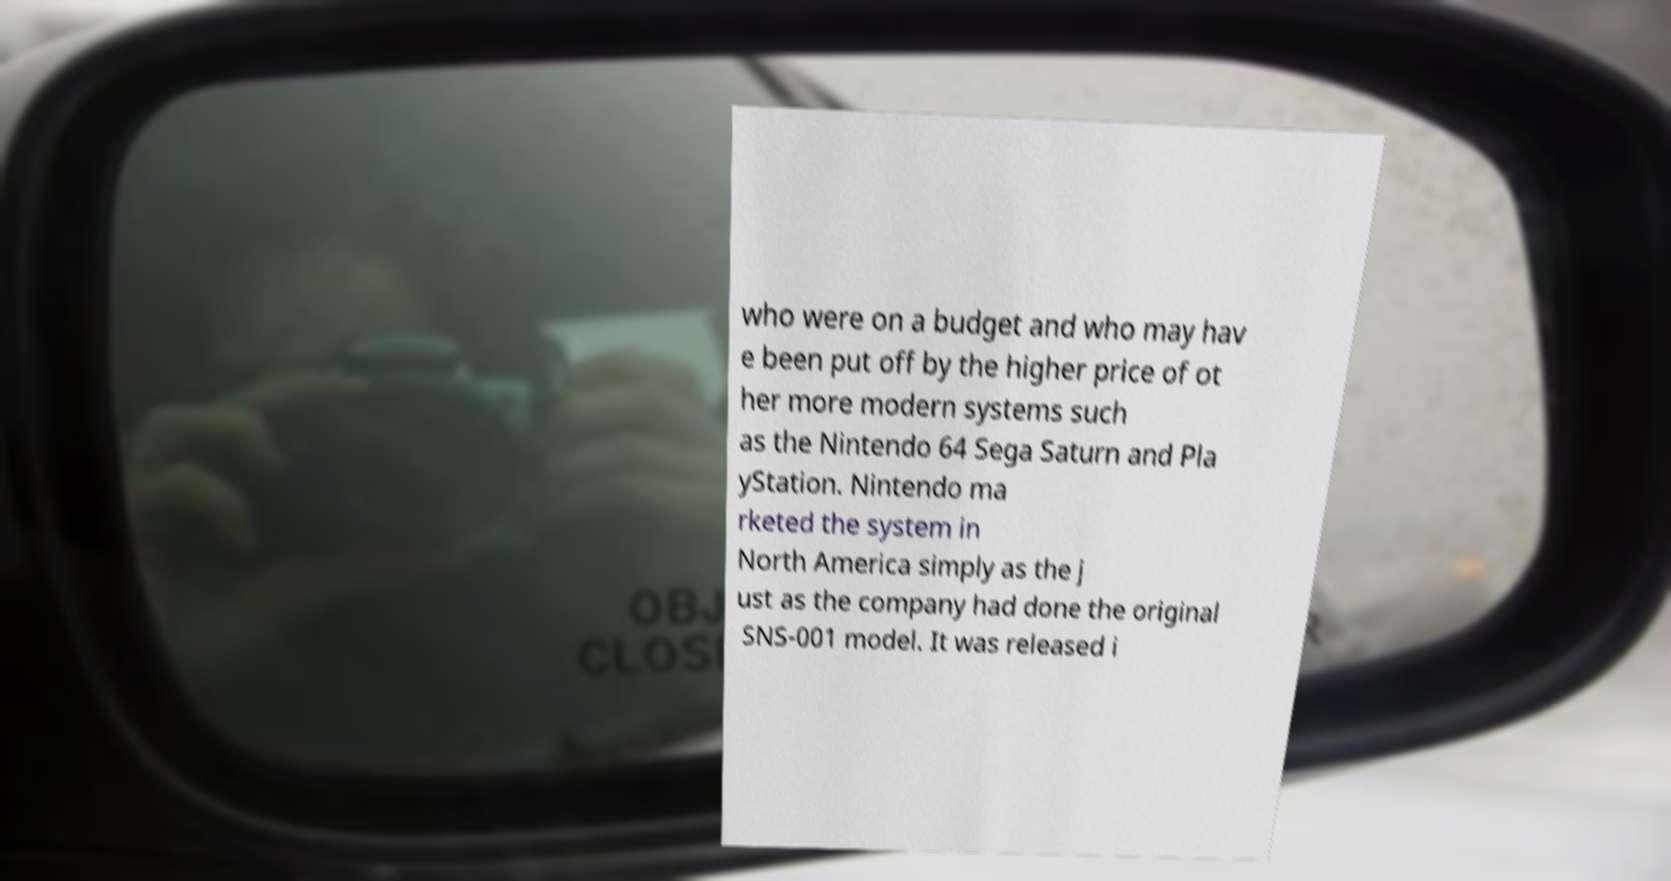Can you read and provide the text displayed in the image?This photo seems to have some interesting text. Can you extract and type it out for me? who were on a budget and who may hav e been put off by the higher price of ot her more modern systems such as the Nintendo 64 Sega Saturn and Pla yStation. Nintendo ma rketed the system in North America simply as the j ust as the company had done the original SNS-001 model. It was released i 